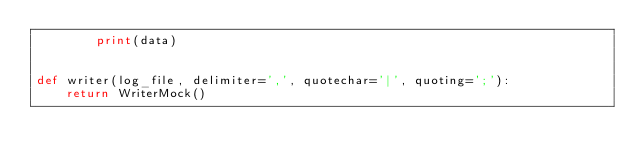<code> <loc_0><loc_0><loc_500><loc_500><_Python_>        print(data)


def writer(log_file, delimiter=',', quotechar='|', quoting=';'):
    return WriterMock()
</code> 